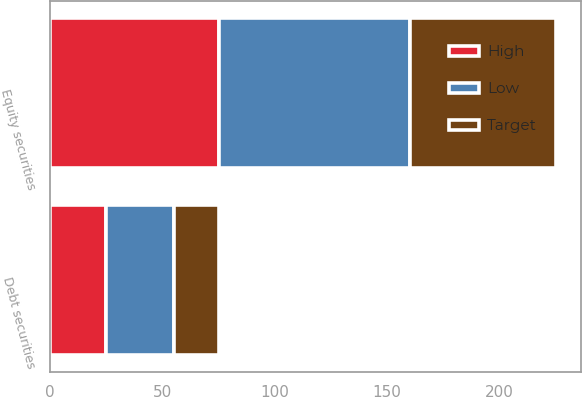Convert chart to OTSL. <chart><loc_0><loc_0><loc_500><loc_500><stacked_bar_chart><ecel><fcel>Debt securities<fcel>Equity securities<nl><fcel>Target<fcel>20<fcel>65<nl><fcel>High<fcel>25<fcel>75<nl><fcel>Low<fcel>30<fcel>85<nl></chart> 